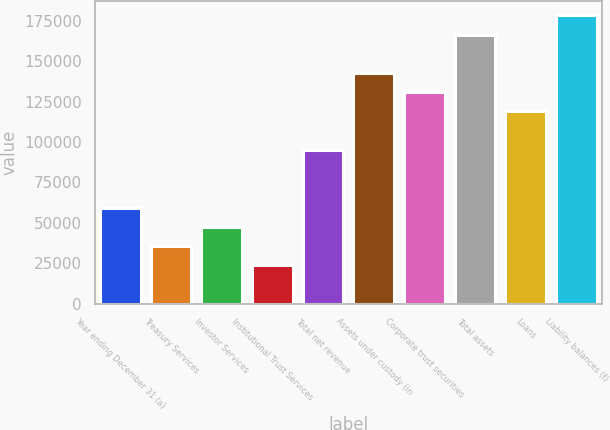<chart> <loc_0><loc_0><loc_500><loc_500><bar_chart><fcel>Year ending December 31 (a)<fcel>Treasury Services<fcel>Investor Services<fcel>Institutional Trust Services<fcel>Total net revenue<fcel>Assets under custody (in<fcel>Corporate trust securities<fcel>Total assets<fcel>Loans<fcel>Liability balances (f)<nl><fcel>59467.5<fcel>35705.3<fcel>47586.4<fcel>23824.2<fcel>95110.8<fcel>142635<fcel>130754<fcel>166397<fcel>118873<fcel>178278<nl></chart> 